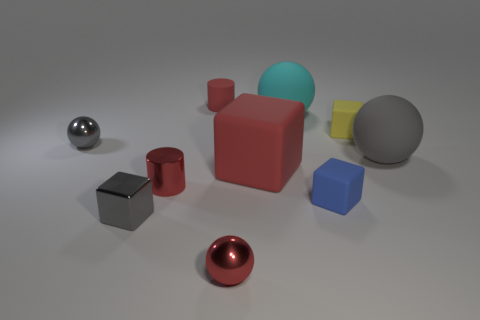There is a tiny blue cube; how many tiny shiny cubes are on the left side of it?
Ensure brevity in your answer.  1. Do the cyan sphere and the small ball that is to the left of the red shiny sphere have the same material?
Your answer should be compact. No. Is there a gray metallic block that has the same size as the gray metallic ball?
Ensure brevity in your answer.  Yes. Are there an equal number of small red spheres behind the blue object and red metallic objects?
Give a very brief answer. No. The gray matte object has what size?
Your answer should be compact. Large. How many metal things are to the left of the small gray shiny object that is to the left of the tiny gray metal block?
Your response must be concise. 0. There is a small red object that is behind the metallic cube and in front of the large gray sphere; what shape is it?
Make the answer very short. Cylinder. How many small metal spheres are the same color as the large matte block?
Your answer should be compact. 1. There is a rubber thing to the right of the rubber block that is behind the big rubber block; is there a rubber cube that is in front of it?
Ensure brevity in your answer.  Yes. There is a gray thing that is both on the left side of the large gray sphere and behind the large red rubber cube; how big is it?
Ensure brevity in your answer.  Small. 